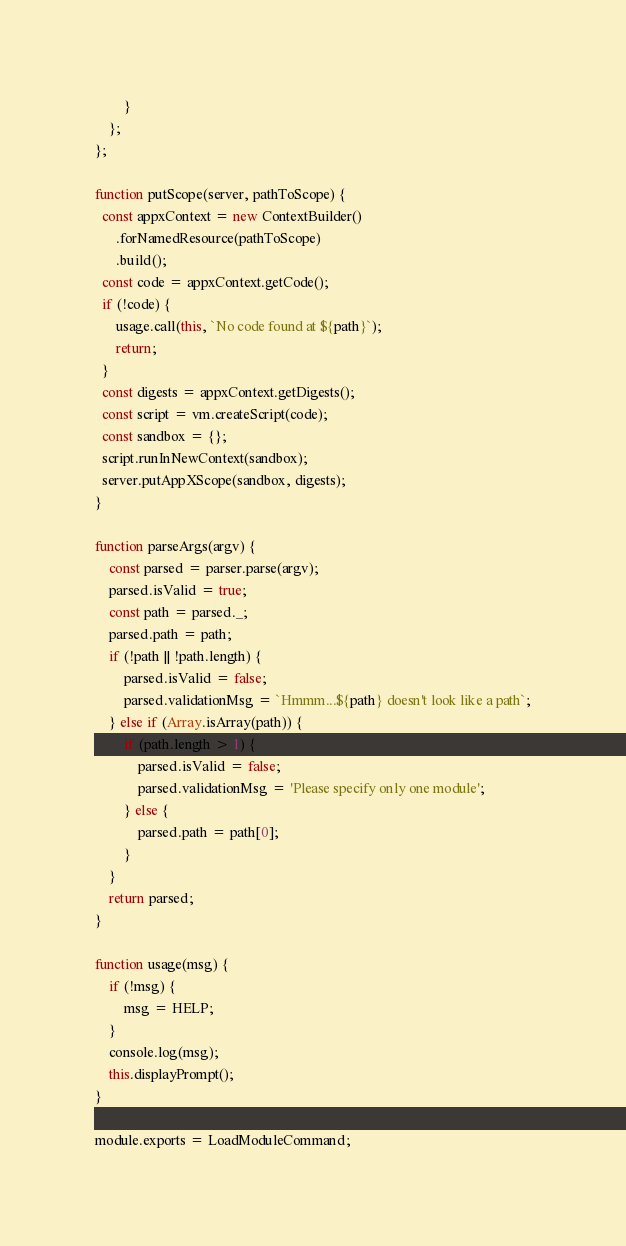<code> <loc_0><loc_0><loc_500><loc_500><_JavaScript_>        }
    };
};

function putScope(server, pathToScope) {
  const appxContext = new ContextBuilder()
      .forNamedResource(pathToScope)
      .build();
  const code = appxContext.getCode();
  if (!code) {
      usage.call(this, `No code found at ${path}`);
      return;
  }
  const digests = appxContext.getDigests();
  const script = vm.createScript(code);
  const sandbox = {};
  script.runInNewContext(sandbox);
  server.putAppXScope(sandbox, digests);
}

function parseArgs(argv) {
    const parsed = parser.parse(argv);
    parsed.isValid = true;
    const path = parsed._;
    parsed.path = path;
    if (!path || !path.length) {
        parsed.isValid = false;
        parsed.validationMsg = `Hmmm...${path} doesn't look like a path`;
    } else if (Array.isArray(path)) {
        if (path.length > 1) {
            parsed.isValid = false;
            parsed.validationMsg = 'Please specify only one module';
        } else {
            parsed.path = path[0];
        }
    }
    return parsed;
}

function usage(msg) {
    if (!msg) {
        msg = HELP;
    }
    console.log(msg);
    this.displayPrompt();
}

module.exports = LoadModuleCommand;
</code> 